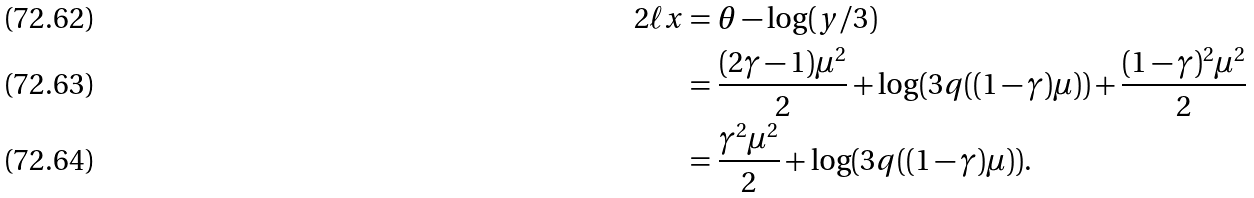<formula> <loc_0><loc_0><loc_500><loc_500>2 \ell x & = \theta - \log ( y / 3 ) \\ & = \frac { ( 2 \gamma - 1 ) \mu ^ { 2 } } { 2 } + \log ( 3 q ( ( 1 - \gamma ) \mu ) ) + \frac { ( 1 - \gamma ) ^ { 2 } \mu ^ { 2 } } { 2 } \\ & = \frac { \gamma ^ { 2 } \mu ^ { 2 } } { 2 } + \log ( 3 q ( ( 1 - \gamma ) \mu ) ) .</formula> 